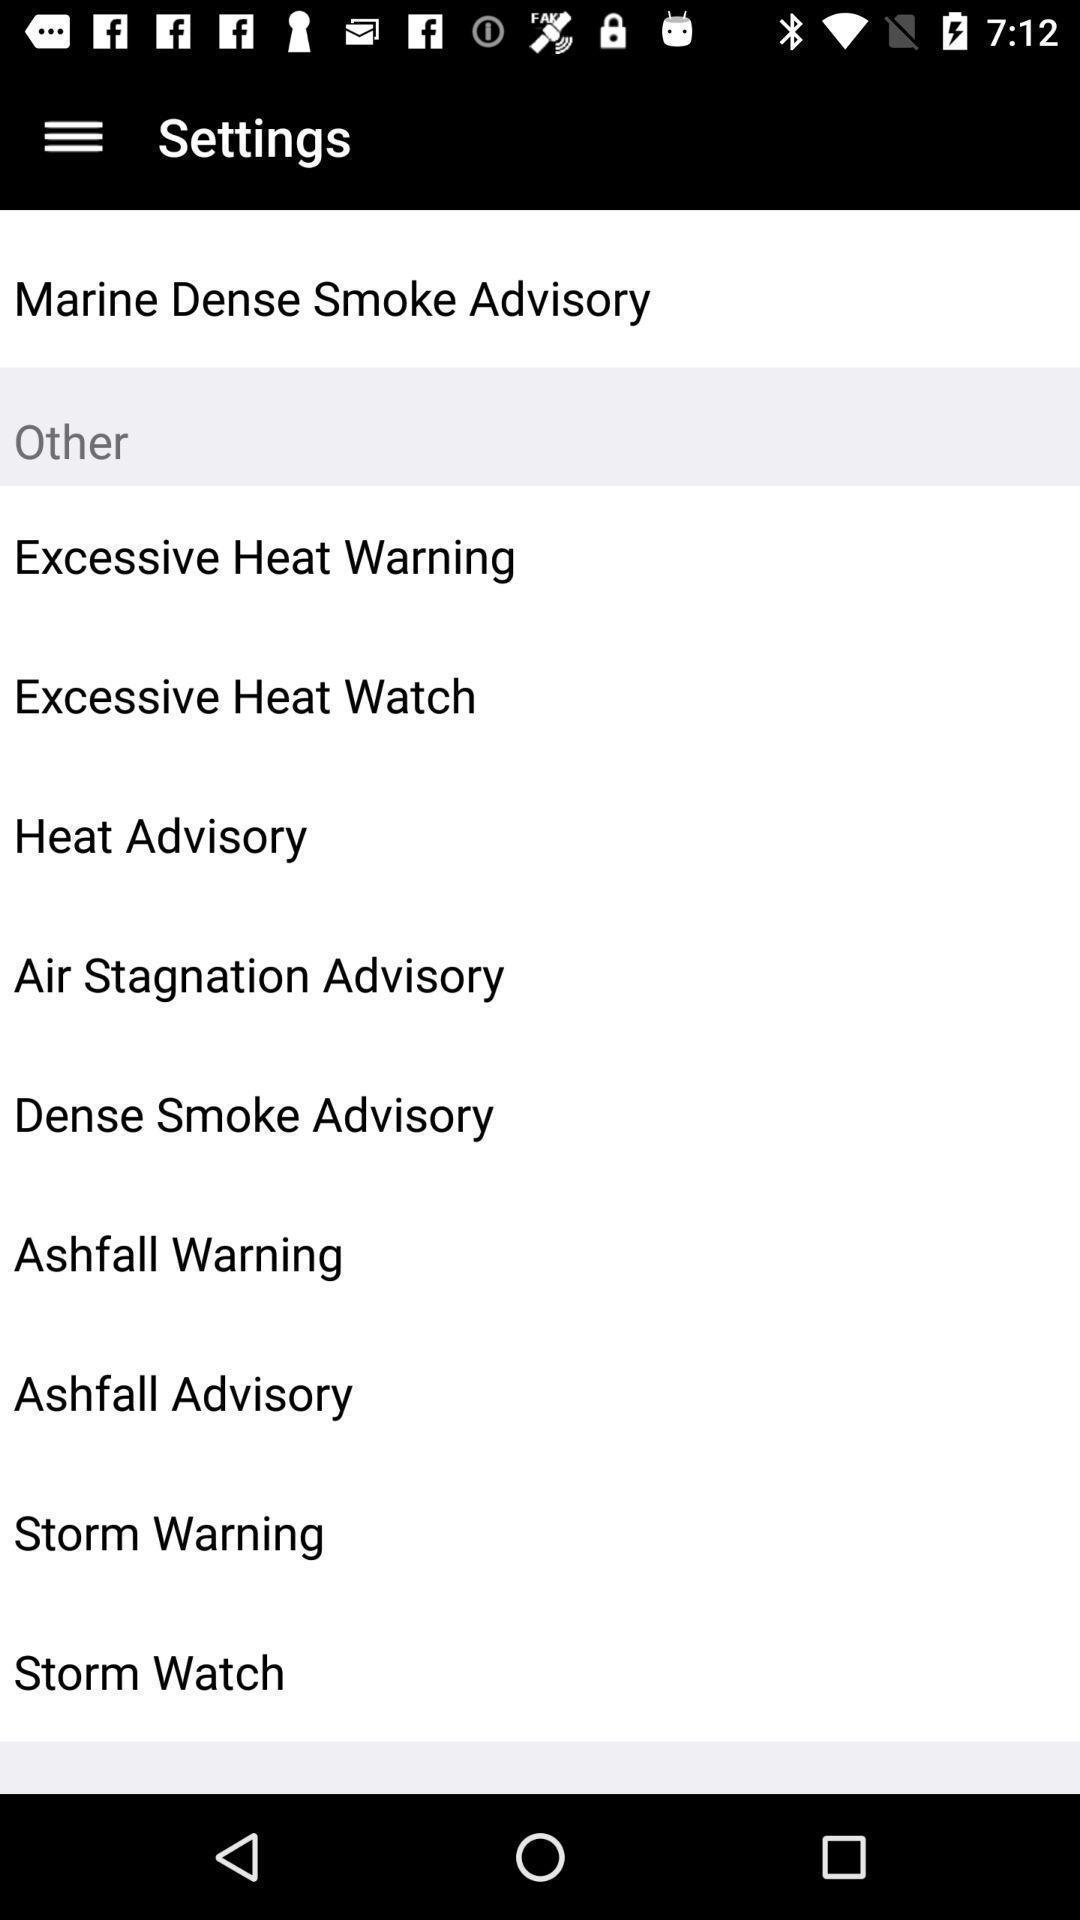Give me a narrative description of this picture. Settings page with multiple options. 